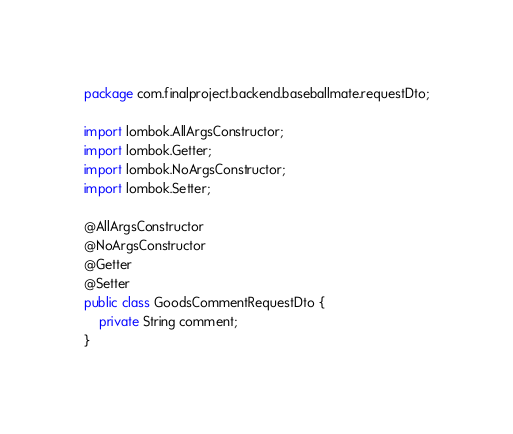Convert code to text. <code><loc_0><loc_0><loc_500><loc_500><_Java_>package com.finalproject.backend.baseballmate.requestDto;

import lombok.AllArgsConstructor;
import lombok.Getter;
import lombok.NoArgsConstructor;
import lombok.Setter;

@AllArgsConstructor
@NoArgsConstructor
@Getter
@Setter
public class GoodsCommentRequestDto {
    private String comment;
}
</code> 